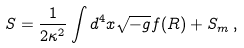Convert formula to latex. <formula><loc_0><loc_0><loc_500><loc_500>S = \frac { 1 } { 2 \kappa ^ { 2 } } \int d ^ { 4 } x \sqrt { - g } f ( R ) + S _ { m } \, ,</formula> 